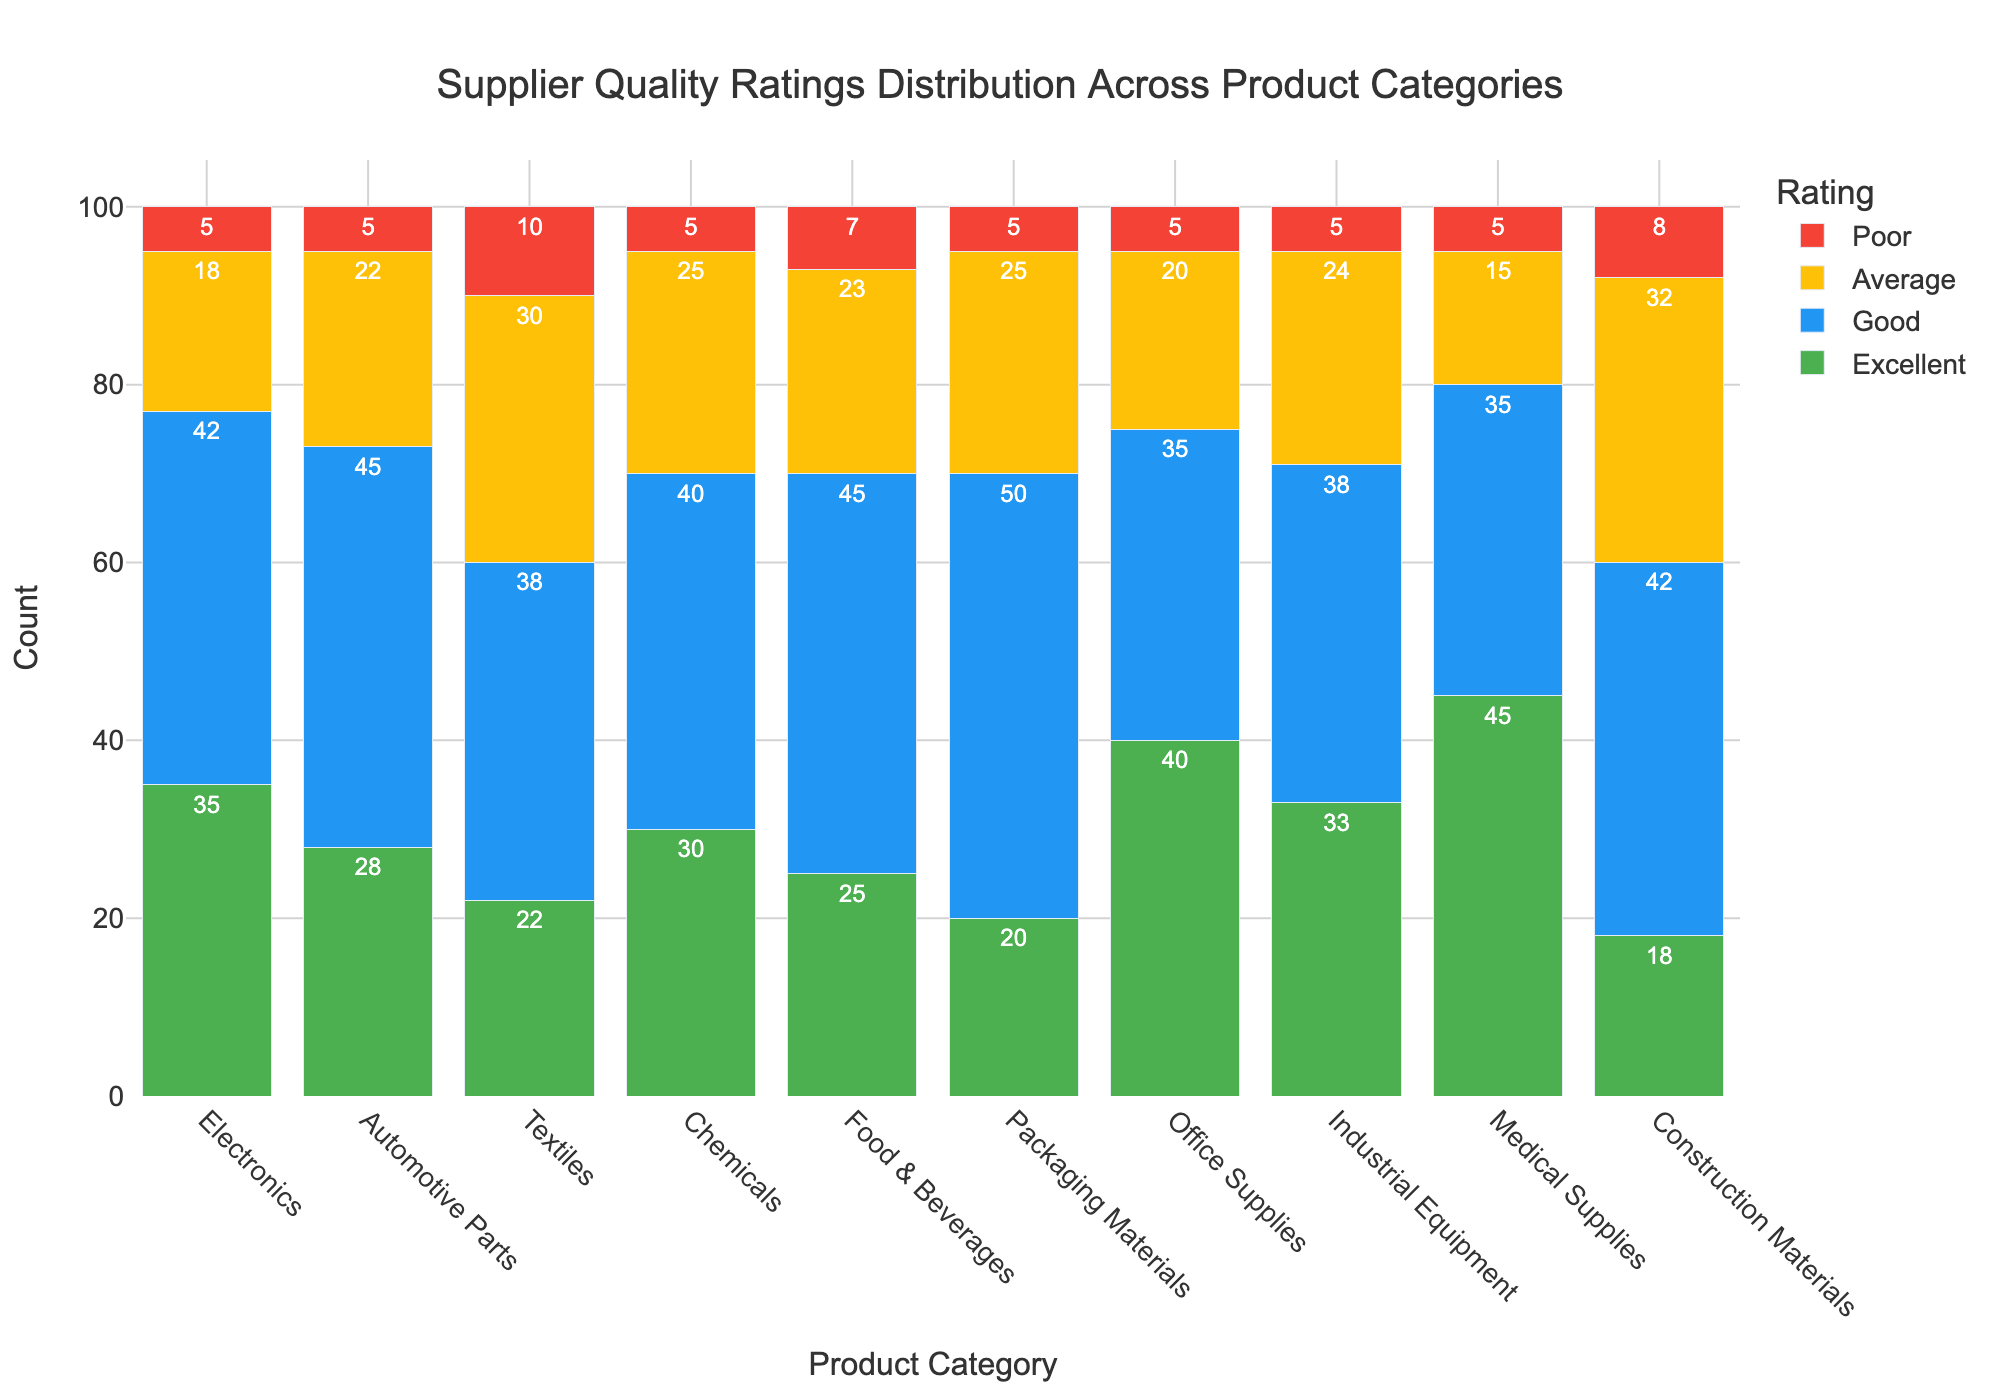Which product category has the highest number of 'Excellent' ratings? Looking at the green bars that represent 'Excellent' ratings, Medical Supplies has the highest numbe with a total of 45.
Answer: Medical Supplies Which product category has the most 'Average' ratings? By observing the yellow bars which represent 'Average' ratings, Construction Materials has the highest number with a total of 32.
Answer: Construction Materials How many total 'Good' ratings are there across all product categories? To find the total, sum the heights of all blue bars for each category: 42 + 45 + 38 + 40 + 45 + 50 + 35 + 38 + 35 + 42 = 410.
Answer: 410 Compare Electronics and Office Supplies: Which has a higher count of 'Poor' ratings? By comparing the red bars for Electronics and Office Supplies, both categories have a count of 5 'Poor' ratings.
Answer: Equal What is the combined total of 'Excellent' and 'Good' ratings for Automotive Parts? Adding the 'Excellent' and 'Good' ratings for Automotive Parts: 28 (Excellent) + 45 (Good) = 73.
Answer: 73 Of all the product categories, which one has the least amount of 'Poor' ratings? Observing the heights of all red bars, several categories including Electronics, Automotive Parts, Chemicals, Packaging Materials, Office Supplies, Industrial Equipment, and Medical Supplies have the lowest amount, each with 5 'Poor' ratings.
Answer: Multiple categories (Electronics, Automotive Parts, Chemicals, Packaging Materials, Office Supplies, Industrial Equipment, Medical Supplies) Is the total count of 'Good' ratings for Textiles more or less than that for Office Supplies? Checking the blue bars, Textiles has 38 'Good' ratings and Office Supplies has 35, so Textiles has more.
Answer: More What is the difference in the number of 'Average' ratings between Chemicals and Textiles? Subtracting the 'Average' ratings of Chemicals from Textiles: 30 (Textiles) - 25 (Chemicals) = 5.
Answer: 5 How does the number of 'Excellent' ratings for Electronics compare to Food & Beverages? The green bar for Electronics shows 35 'Excellent' ratings, while Food & Beverages shows 25, so Electronics has more.
Answer: More In total, which rating category has the highest combined count across all product categories? Adding up each rating category: 
'Excellent': 35+28+22+30+25+20+40+33+45+18 = 296
'Good': 42+45+38+40+45+50+35+38+35+42 = 410
'Average': 18+22+30+25+23+25+20+24+15+32 = 234
'Poor': 5+5+10+5+7+5+5+5+5+8 = 60
The 'Good' category has the highest combined count of 410.
Answer: Good 